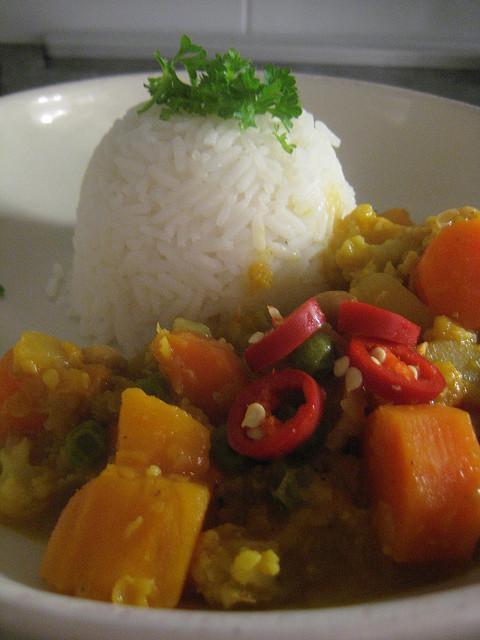How many carrots can you see?
Give a very brief answer. 4. How many  bikes are pictured?
Give a very brief answer. 0. 